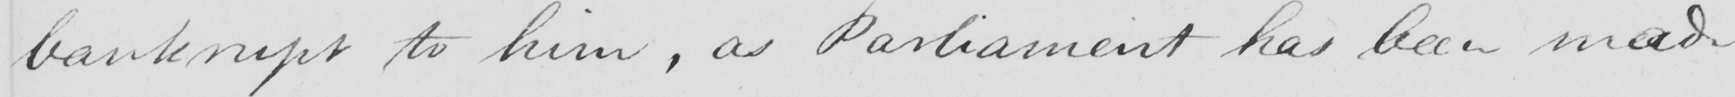Can you tell me what this handwritten text says? bankrupt to him , as Parliament has been made 